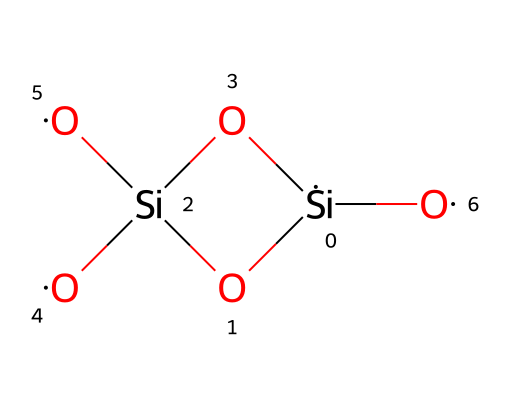What is the main element in this chemical structure? The central element in this SMILES representation is silicon, denoted by the symbol [Si]. It plays a crucial role in the overall structure of the compound, which is clearly visible as the primary atom.
Answer: silicon How many oxygen atoms are present in this chemical? By analyzing the SMILES string, we can identify each occurrence of [O]. There are a total of four oxygen atoms present in the structure, evident from the multiple occurrences in the representation.
Answer: four What type of ceramic is represented by this chemical? This chemical depicts a silicate ceramic, as it consists mainly of silicon and oxygen atoms in a specific arrangement, commonly found in silicate ceramics used for their durability and thermal resistance.
Answer: silicate What is the bonding type among the atoms in this ceramic structure? The bonding type in this chemical primarily involves covalent bonds between silicon and oxygen atoms. The close proximity of these atoms in the SMILES string suggests that they are sharing electrons, characteristic of covalent bonding.
Answer: covalent Which functional group can be identified in the chemical structure? The presence of multiple hydroxyl groups (-OH) indicates that this ceramic has silanol functional groups in its structure. Hydroxyl groups contribute to unique properties such as increased reactivity and hydrophilicity.
Answer: silanol Can you determine the hybridization of the silicon atom in this chemical? In the provided structure, silicon exhibits sp3 hybridization due to its four single covalent bonds to oxygen atoms, indicating that it is forming four sigma bonds. This hybridization leads to a tetrahedral arrangement.
Answer: sp3 